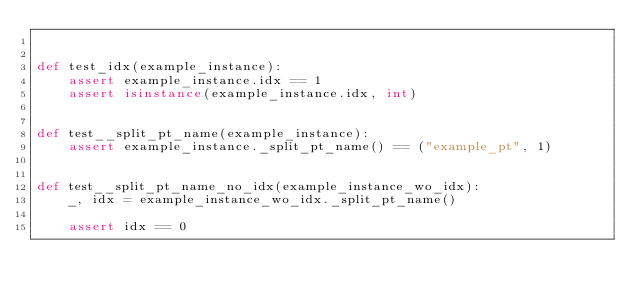<code> <loc_0><loc_0><loc_500><loc_500><_Python_>

def test_idx(example_instance):
    assert example_instance.idx == 1
    assert isinstance(example_instance.idx, int)


def test__split_pt_name(example_instance):
    assert example_instance._split_pt_name() == ("example_pt", 1)


def test__split_pt_name_no_idx(example_instance_wo_idx):
    _, idx = example_instance_wo_idx._split_pt_name()

    assert idx == 0
</code> 